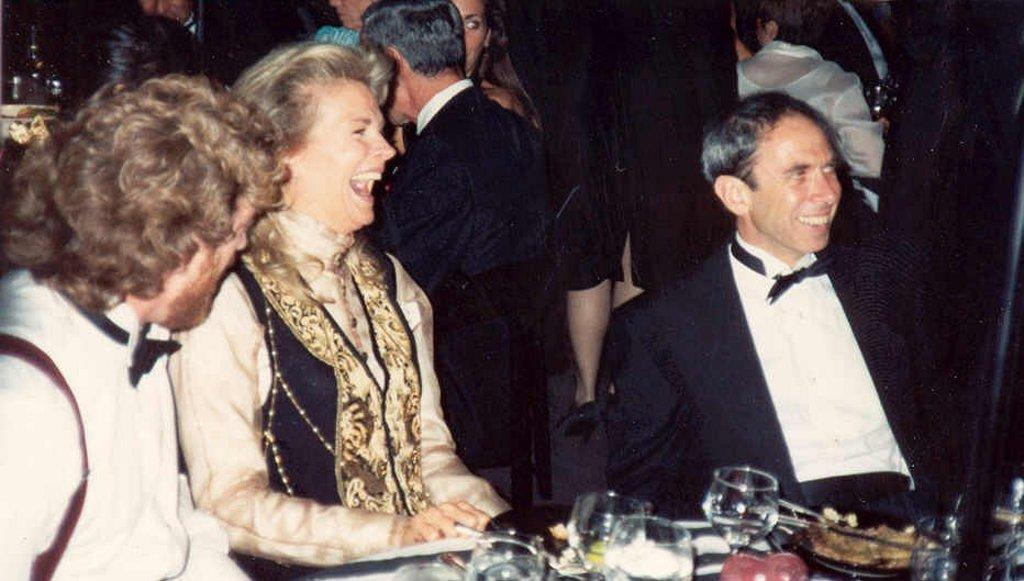What are the people in the image doing? The people in the image are sitting. What objects can be seen in the image besides the people? There are glasses visible in the image. What type of crook is visible in the image? There is no crook present in the image. Who are the people sitting with in the image? The facts provided do not specify the relationships between the people in the image. 